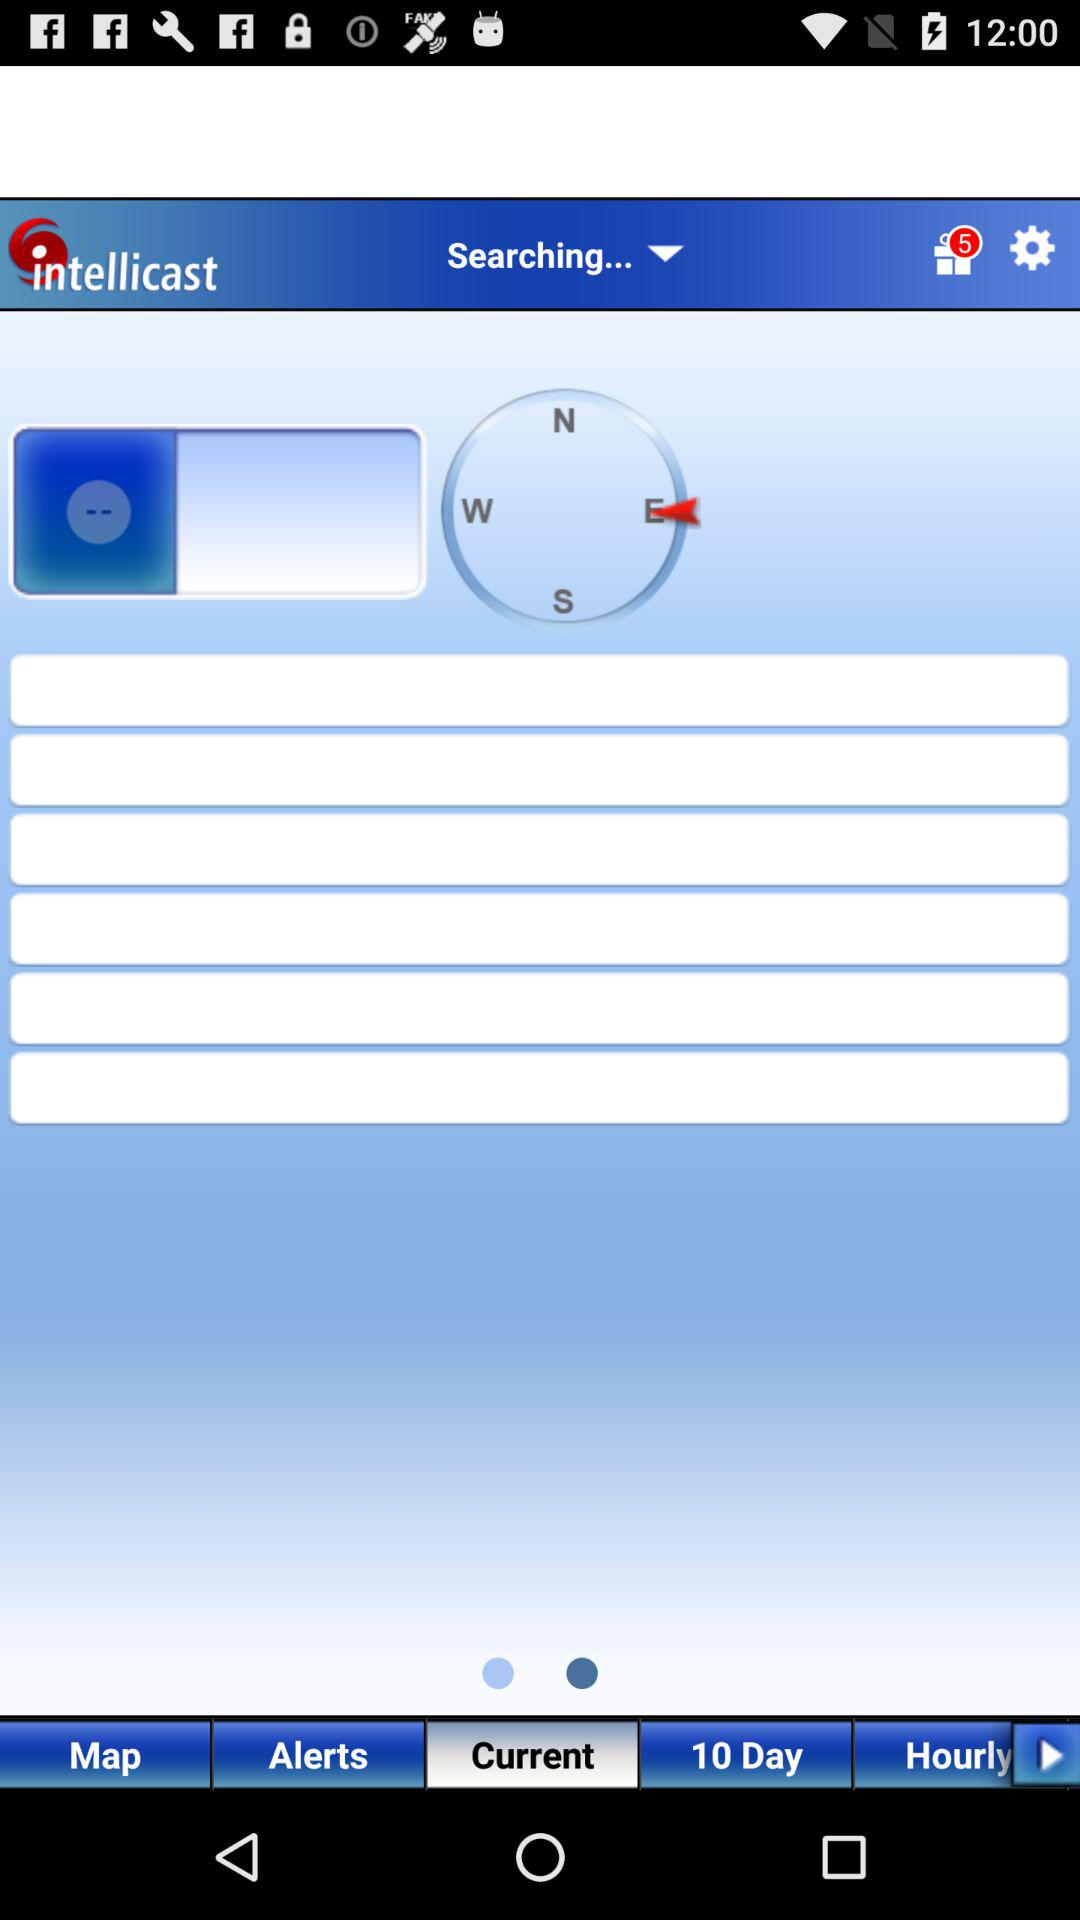How many unopened gifts are there? There are 5 unopened gifts. 